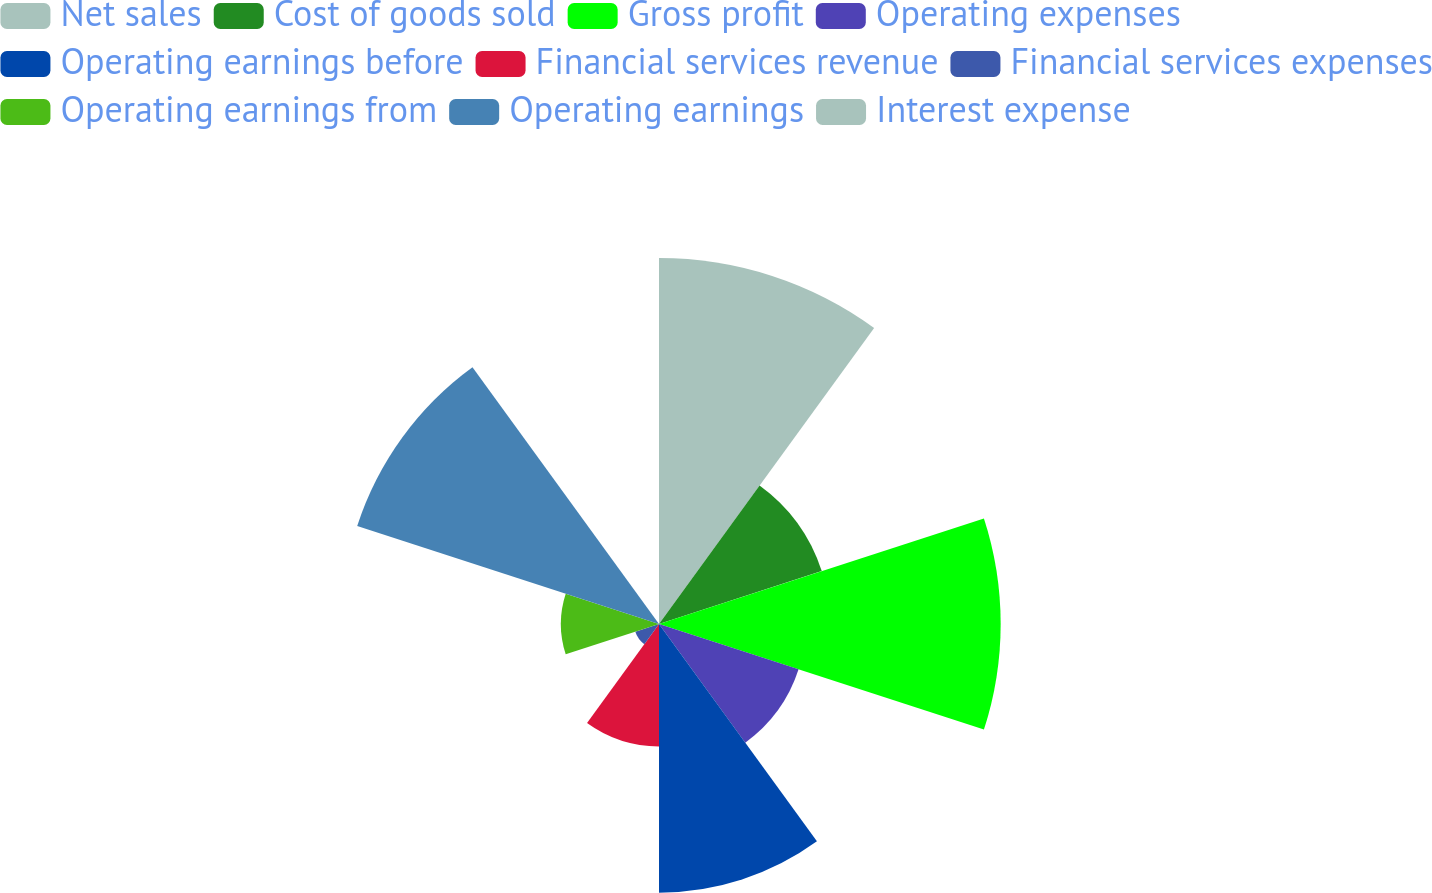Convert chart to OTSL. <chart><loc_0><loc_0><loc_500><loc_500><pie_chart><fcel>Net sales<fcel>Cost of goods sold<fcel>Gross profit<fcel>Operating expenses<fcel>Operating earnings before<fcel>Financial services revenue<fcel>Financial services expenses<fcel>Operating earnings from<fcel>Operating earnings<fcel>Interest expense<nl><fcel>19.7%<fcel>9.21%<fcel>18.39%<fcel>7.9%<fcel>14.46%<fcel>6.59%<fcel>1.34%<fcel>5.28%<fcel>17.08%<fcel>0.03%<nl></chart> 